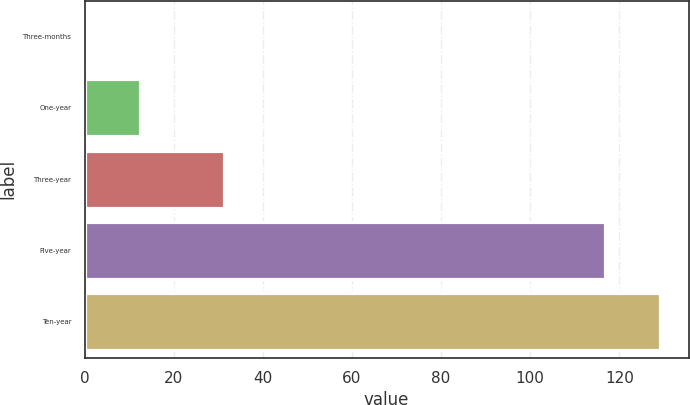<chart> <loc_0><loc_0><loc_500><loc_500><bar_chart><fcel>Three-months<fcel>One-year<fcel>Three-year<fcel>Five-year<fcel>Ten-year<nl><fcel>0.1<fcel>12.5<fcel>31.2<fcel>116.7<fcel>129.1<nl></chart> 